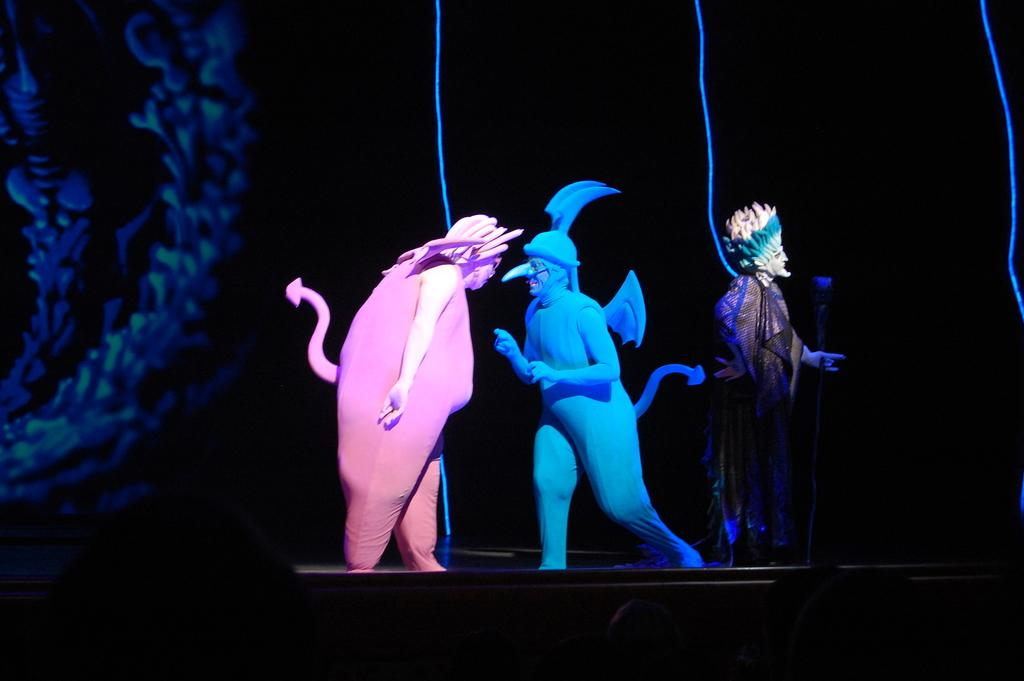How many people are in the image? There are three people in the image. What are the people wearing? The people are wearing fancy dresses. What can be seen hanging in the image? Blue ropes are hanging in the image. How would you describe the lighting in the image? The background of the image appears dark. Where is the design located in the image? The design is on the left side of the image. What type of pizzas are being served in the image? There are no pizzas present in the image. What time of day is it in the image? The provided facts do not give any information about the time of day, so it cannot be determined from the image. 